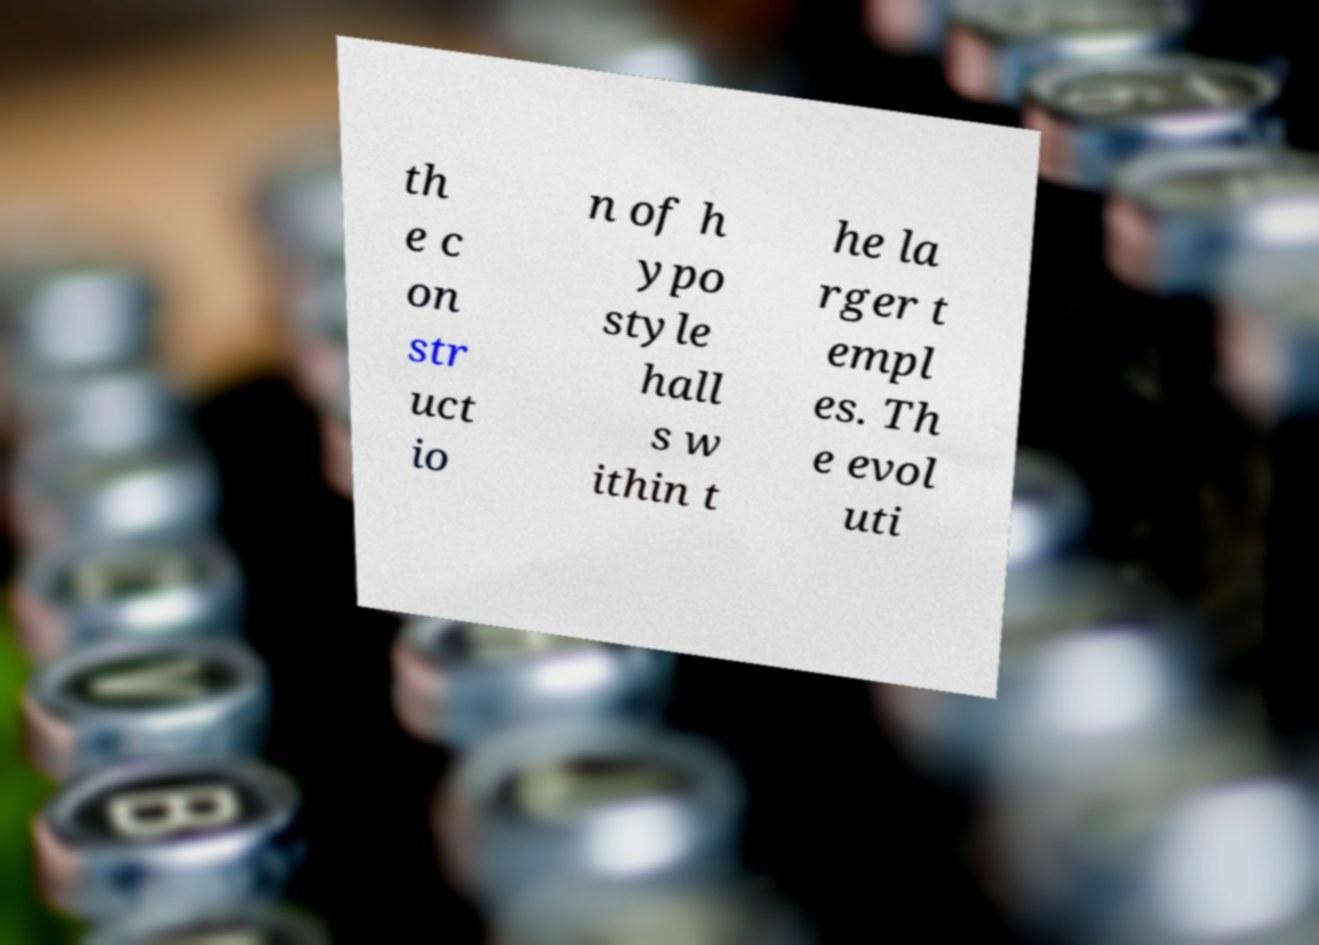Could you extract and type out the text from this image? th e c on str uct io n of h ypo style hall s w ithin t he la rger t empl es. Th e evol uti 